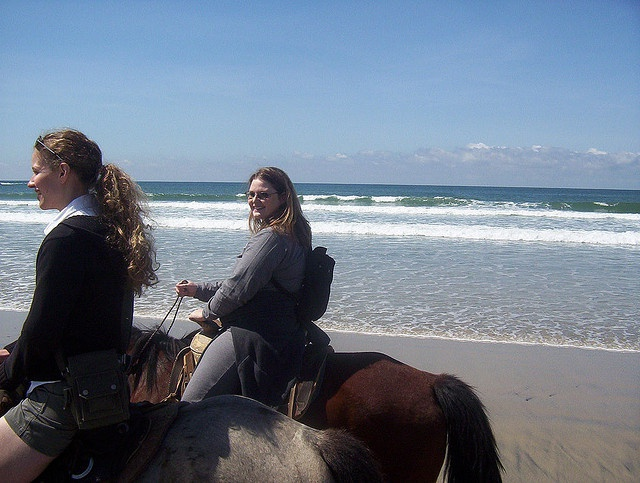Describe the objects in this image and their specific colors. I can see people in gray, black, and darkgray tones, people in gray, black, and darkgray tones, horse in gray, black, and maroon tones, horse in gray and black tones, and handbag in gray and black tones in this image. 